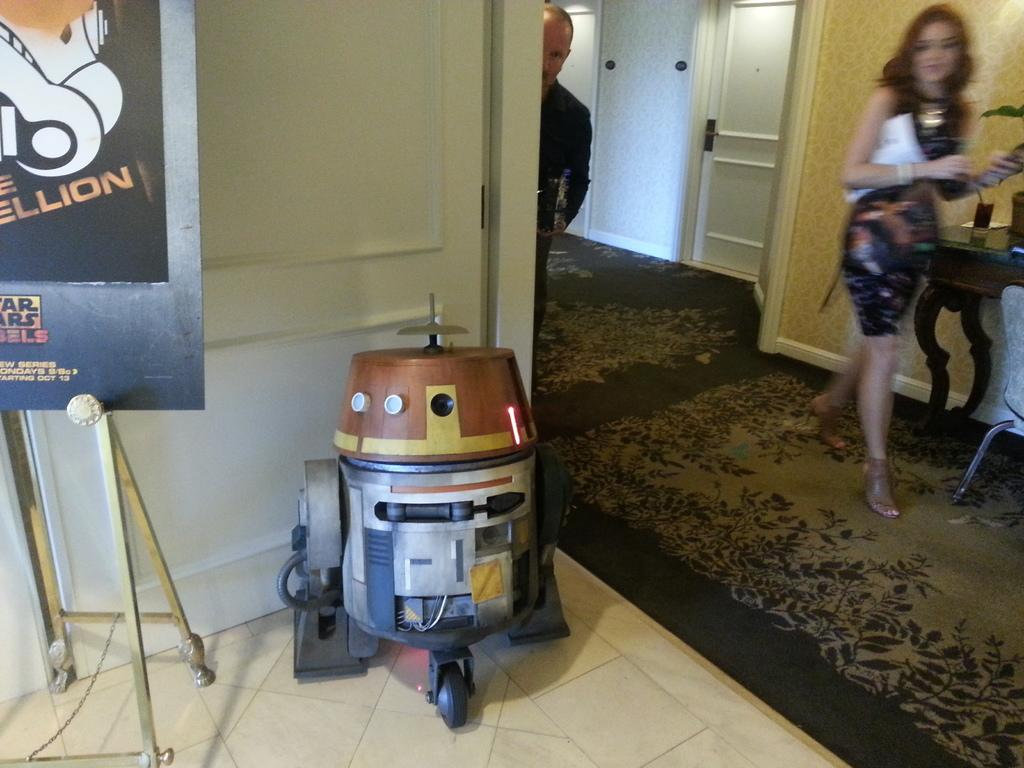<image>
Relay a brief, clear account of the picture shown. A small STar Wars robot next to a sign that's cut off in the picture that has the words ellion 